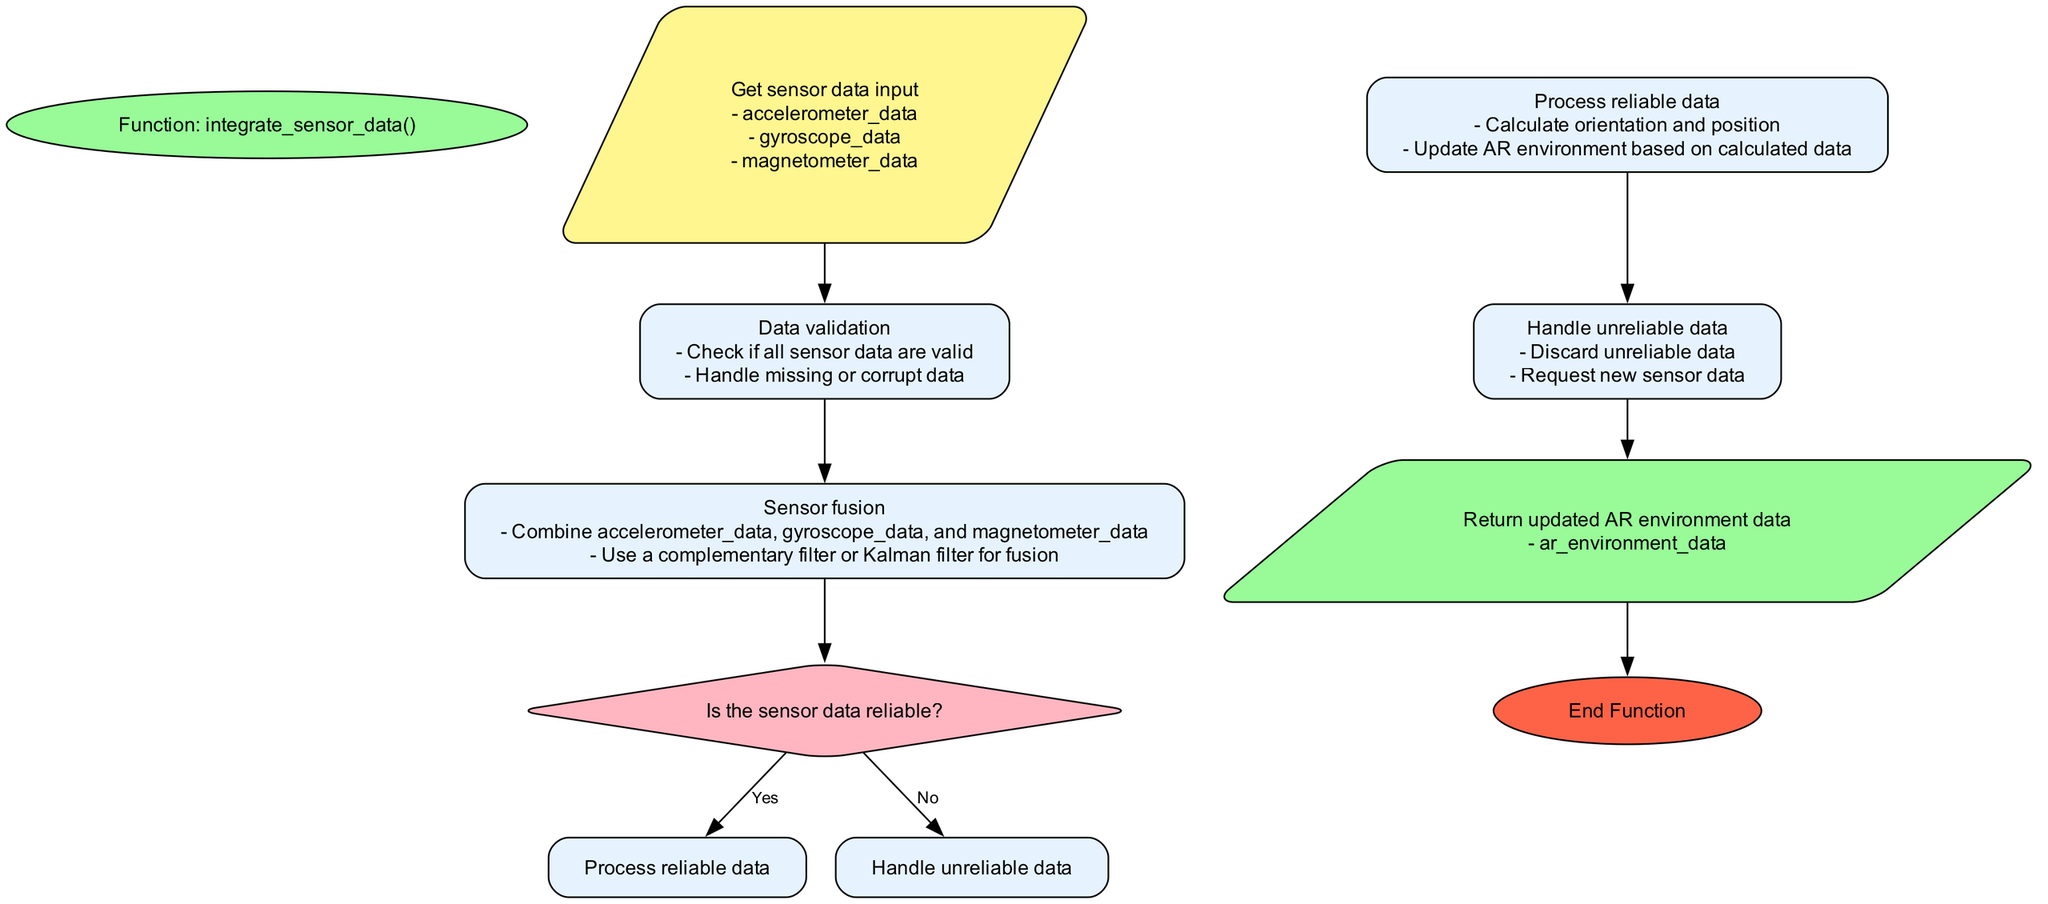What is the starting node of the function? The diagram begins at the node labeled "Function: integrate_sensor_data()". This is the first node and serves as the entry point of the function.
Answer: Function: integrate_sensor_data() How many types of sensor data are inputted? There are three types of sensor data mentioned in the diagram: accelerometer_data, gyroscope_data, and magnetometer_data. This is indicated in the input node.
Answer: Three What does the decision node ask? The decision node asks the question "Is the sensor data reliable?". This is a critical point in the flowchart that determines the path taken based on data reliability.
Answer: Is the sensor data reliable? What happens if the sensor data is unreliable? If the sensor data is deemed unreliable, the flow leads to the "Handle unreliable data" process, where it instructs to discard the unreliable data and request new sensor data.
Answer: Discard unreliable data Which process calculates orientation and position? The "Process reliable data" step is responsible for calculating orientation and position based on the reliable sensor data received.
Answer: Process reliable data What is the output of the function? The output of the function is "Return updated AR environment data", which includes orientation, position, and timestamp. This represents the end result of the entire process.
Answer: Return updated AR environment data What connects the input node to the data validation process? An edge connects the "Get sensor data input" node to the "Data validation" process, indicating the flow of operations from data input to the validation step.
Answer: An edge What shape is used for process nodes? Process nodes in the flowchart are represented using a rectangle shape according to the diagram's conventions, which denotes an action or a series of operations in the function.
Answer: Rectangle Which process is executed if the sensor data is reliable? If the sensor data is reliable, the flow proceeds to the "Process reliable data", where calculations for orientation and position are made based on the sensory inputs.
Answer: Process reliable data 